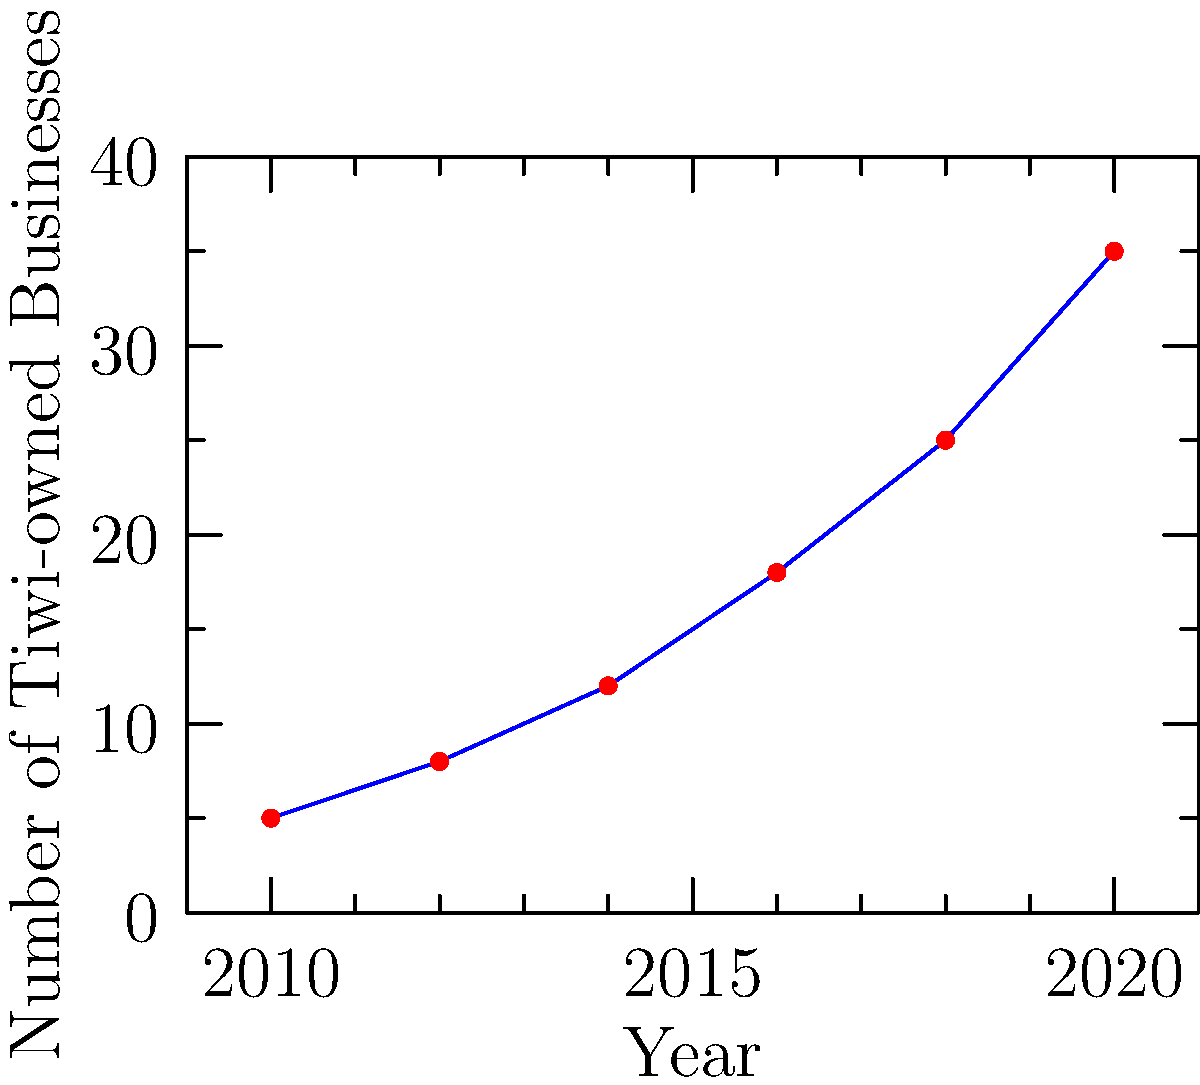Analyze the growth trend of Tiwi-owned businesses from 2010 to 2020. What was the average increase in the number of businesses every two years during this period? To find the average increase in Tiwi-owned businesses every two years:

1. Calculate the total increase from 2010 to 2020:
   Businesses in 2020: 35
   Businesses in 2010: 5
   Total increase: 35 - 5 = 30

2. Count the number of two-year periods from 2010 to 2020:
   2010-2012, 2012-2014, 2014-2016, 2016-2018, 2018-2020
   Total: 5 two-year periods

3. Calculate the average increase:
   Average increase = Total increase ÷ Number of periods
   $\frac{30}{5} = 6$

Therefore, the average increase in Tiwi-owned businesses every two years from 2010 to 2020 was 6.
Answer: 6 businesses 